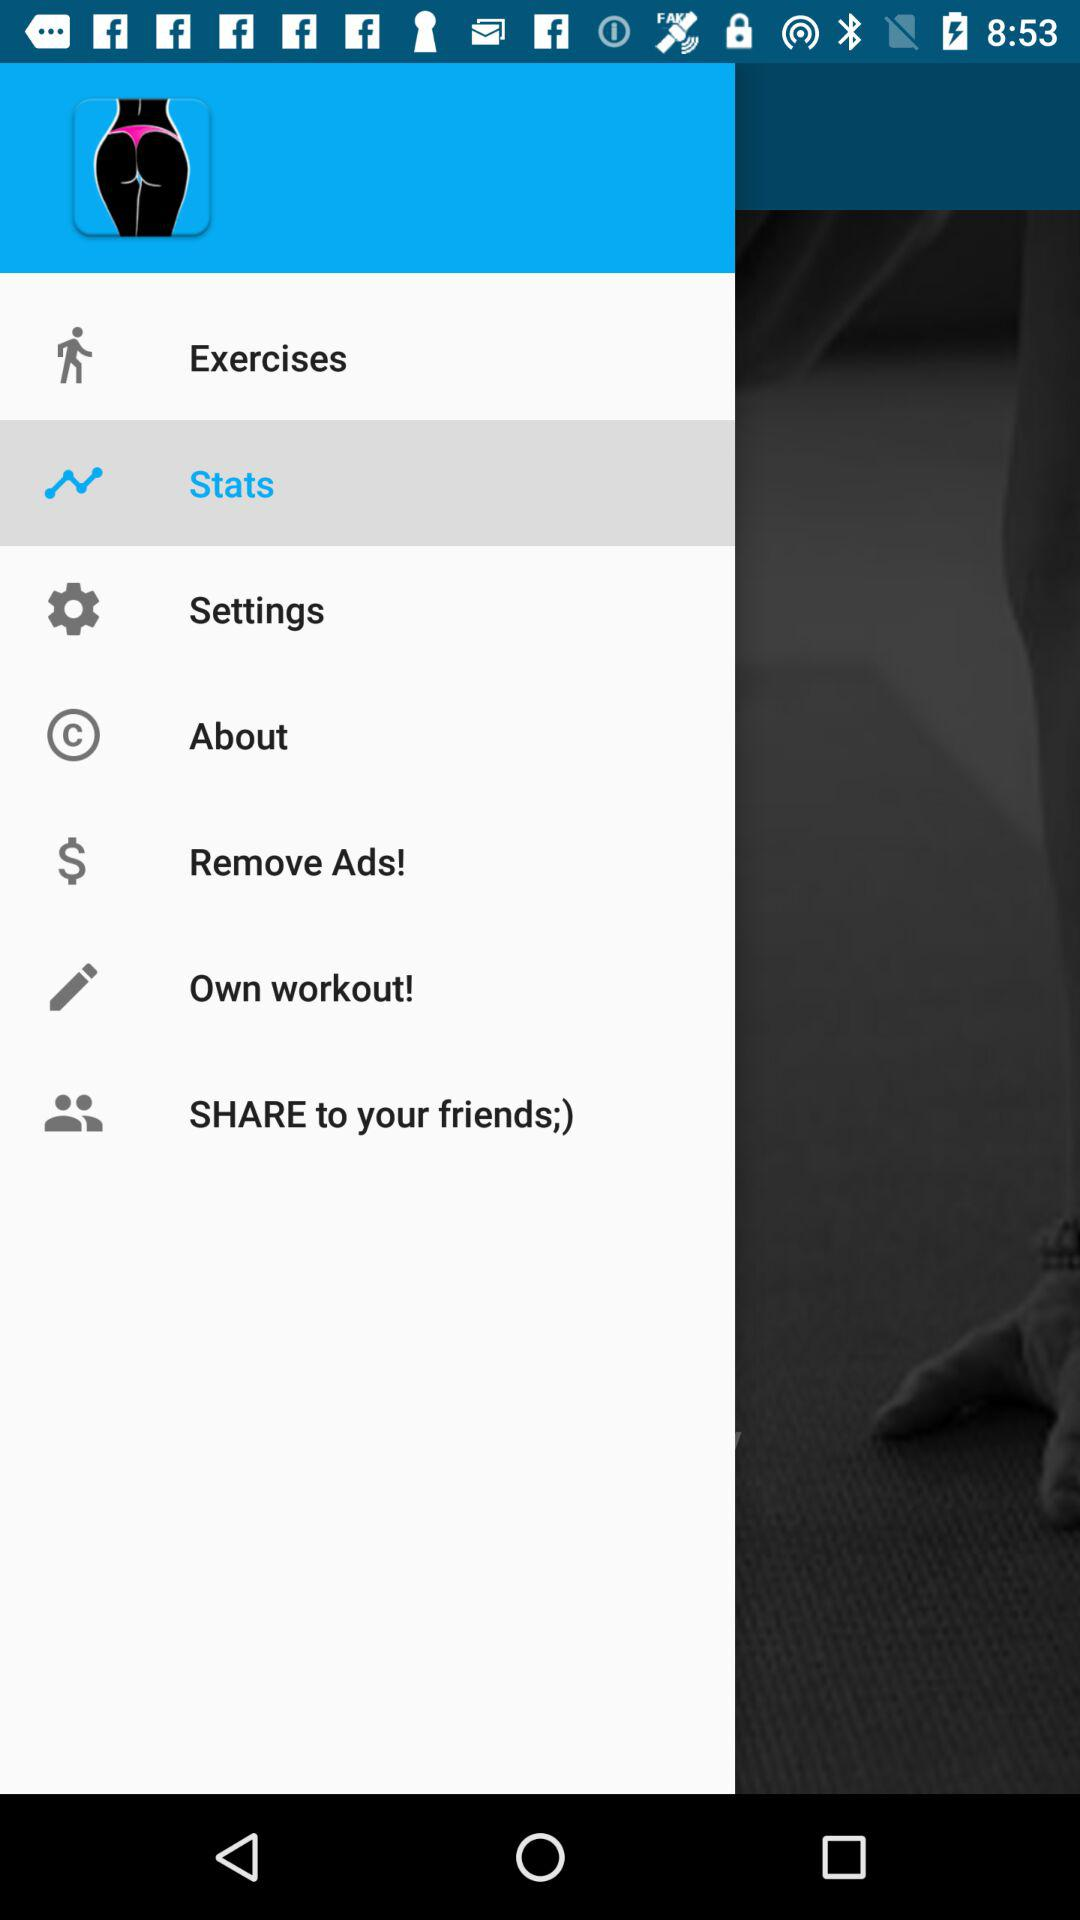Which option is selected? The selected option is "Stats". 